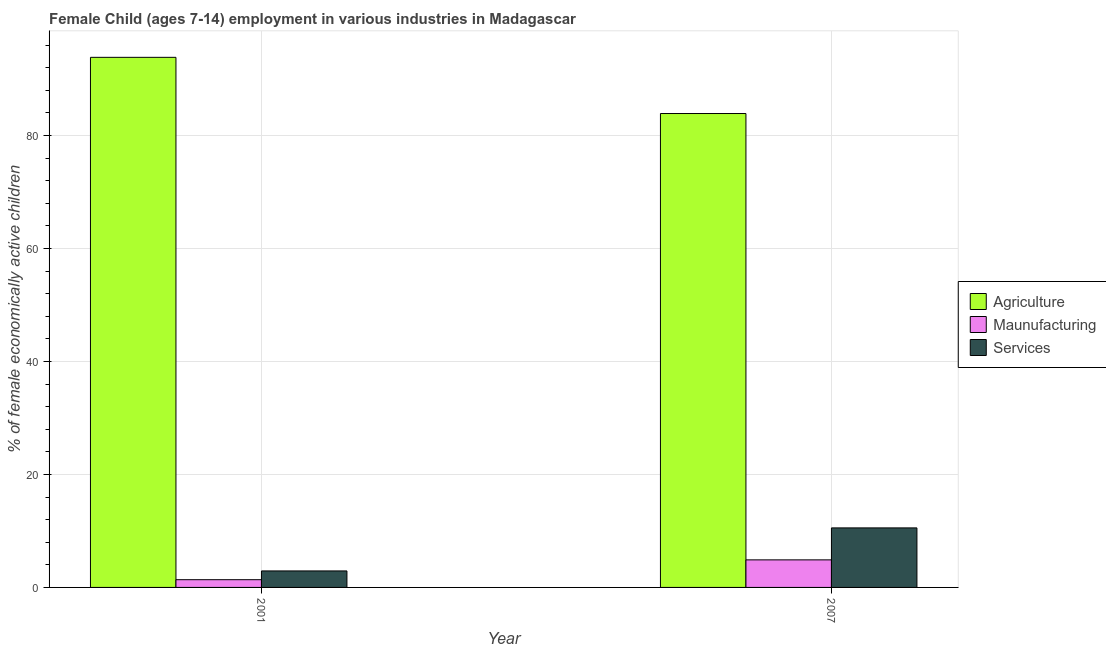Are the number of bars on each tick of the X-axis equal?
Give a very brief answer. Yes. How many bars are there on the 2nd tick from the right?
Your answer should be very brief. 3. In how many cases, is the number of bars for a given year not equal to the number of legend labels?
Offer a terse response. 0. What is the percentage of economically active children in agriculture in 2007?
Provide a short and direct response. 83.9. Across all years, what is the maximum percentage of economically active children in services?
Give a very brief answer. 10.54. Across all years, what is the minimum percentage of economically active children in manufacturing?
Offer a very short reply. 1.37. In which year was the percentage of economically active children in manufacturing minimum?
Give a very brief answer. 2001. What is the total percentage of economically active children in manufacturing in the graph?
Give a very brief answer. 6.25. What is the difference between the percentage of economically active children in manufacturing in 2001 and that in 2007?
Offer a very short reply. -3.51. What is the difference between the percentage of economically active children in agriculture in 2007 and the percentage of economically active children in manufacturing in 2001?
Offer a terse response. -9.95. What is the average percentage of economically active children in manufacturing per year?
Provide a short and direct response. 3.12. In the year 2007, what is the difference between the percentage of economically active children in agriculture and percentage of economically active children in manufacturing?
Provide a succinct answer. 0. In how many years, is the percentage of economically active children in manufacturing greater than 4 %?
Offer a terse response. 1. What is the ratio of the percentage of economically active children in agriculture in 2001 to that in 2007?
Ensure brevity in your answer.  1.12. What does the 1st bar from the left in 2001 represents?
Make the answer very short. Agriculture. What does the 2nd bar from the right in 2007 represents?
Your response must be concise. Maunufacturing. Is it the case that in every year, the sum of the percentage of economically active children in agriculture and percentage of economically active children in manufacturing is greater than the percentage of economically active children in services?
Your answer should be very brief. Yes. What is the difference between two consecutive major ticks on the Y-axis?
Provide a short and direct response. 20. Are the values on the major ticks of Y-axis written in scientific E-notation?
Your answer should be compact. No. Does the graph contain any zero values?
Ensure brevity in your answer.  No. Where does the legend appear in the graph?
Provide a succinct answer. Center right. What is the title of the graph?
Provide a short and direct response. Female Child (ages 7-14) employment in various industries in Madagascar. What is the label or title of the Y-axis?
Offer a terse response. % of female economically active children. What is the % of female economically active children in Agriculture in 2001?
Provide a short and direct response. 93.85. What is the % of female economically active children of Maunufacturing in 2001?
Make the answer very short. 1.37. What is the % of female economically active children in Services in 2001?
Ensure brevity in your answer.  2.92. What is the % of female economically active children in Agriculture in 2007?
Give a very brief answer. 83.9. What is the % of female economically active children in Maunufacturing in 2007?
Offer a terse response. 4.88. What is the % of female economically active children in Services in 2007?
Offer a very short reply. 10.54. Across all years, what is the maximum % of female economically active children of Agriculture?
Offer a very short reply. 93.85. Across all years, what is the maximum % of female economically active children in Maunufacturing?
Your answer should be very brief. 4.88. Across all years, what is the maximum % of female economically active children of Services?
Give a very brief answer. 10.54. Across all years, what is the minimum % of female economically active children of Agriculture?
Ensure brevity in your answer.  83.9. Across all years, what is the minimum % of female economically active children in Maunufacturing?
Provide a succinct answer. 1.37. Across all years, what is the minimum % of female economically active children of Services?
Ensure brevity in your answer.  2.92. What is the total % of female economically active children of Agriculture in the graph?
Offer a terse response. 177.75. What is the total % of female economically active children of Maunufacturing in the graph?
Your answer should be very brief. 6.25. What is the total % of female economically active children in Services in the graph?
Offer a very short reply. 13.46. What is the difference between the % of female economically active children of Agriculture in 2001 and that in 2007?
Offer a terse response. 9.95. What is the difference between the % of female economically active children in Maunufacturing in 2001 and that in 2007?
Offer a terse response. -3.51. What is the difference between the % of female economically active children of Services in 2001 and that in 2007?
Keep it short and to the point. -7.62. What is the difference between the % of female economically active children in Agriculture in 2001 and the % of female economically active children in Maunufacturing in 2007?
Offer a terse response. 88.97. What is the difference between the % of female economically active children of Agriculture in 2001 and the % of female economically active children of Services in 2007?
Your answer should be compact. 83.31. What is the difference between the % of female economically active children of Maunufacturing in 2001 and the % of female economically active children of Services in 2007?
Keep it short and to the point. -9.17. What is the average % of female economically active children of Agriculture per year?
Keep it short and to the point. 88.88. What is the average % of female economically active children of Maunufacturing per year?
Your response must be concise. 3.12. What is the average % of female economically active children of Services per year?
Make the answer very short. 6.73. In the year 2001, what is the difference between the % of female economically active children of Agriculture and % of female economically active children of Maunufacturing?
Your response must be concise. 92.48. In the year 2001, what is the difference between the % of female economically active children in Agriculture and % of female economically active children in Services?
Keep it short and to the point. 90.93. In the year 2001, what is the difference between the % of female economically active children in Maunufacturing and % of female economically active children in Services?
Provide a short and direct response. -1.55. In the year 2007, what is the difference between the % of female economically active children of Agriculture and % of female economically active children of Maunufacturing?
Keep it short and to the point. 79.02. In the year 2007, what is the difference between the % of female economically active children of Agriculture and % of female economically active children of Services?
Offer a very short reply. 73.36. In the year 2007, what is the difference between the % of female economically active children of Maunufacturing and % of female economically active children of Services?
Offer a very short reply. -5.66. What is the ratio of the % of female economically active children in Agriculture in 2001 to that in 2007?
Provide a short and direct response. 1.12. What is the ratio of the % of female economically active children of Maunufacturing in 2001 to that in 2007?
Offer a very short reply. 0.28. What is the ratio of the % of female economically active children of Services in 2001 to that in 2007?
Your response must be concise. 0.28. What is the difference between the highest and the second highest % of female economically active children of Agriculture?
Provide a short and direct response. 9.95. What is the difference between the highest and the second highest % of female economically active children in Maunufacturing?
Your answer should be very brief. 3.51. What is the difference between the highest and the second highest % of female economically active children of Services?
Offer a very short reply. 7.62. What is the difference between the highest and the lowest % of female economically active children of Agriculture?
Your answer should be very brief. 9.95. What is the difference between the highest and the lowest % of female economically active children of Maunufacturing?
Offer a terse response. 3.51. What is the difference between the highest and the lowest % of female economically active children of Services?
Make the answer very short. 7.62. 